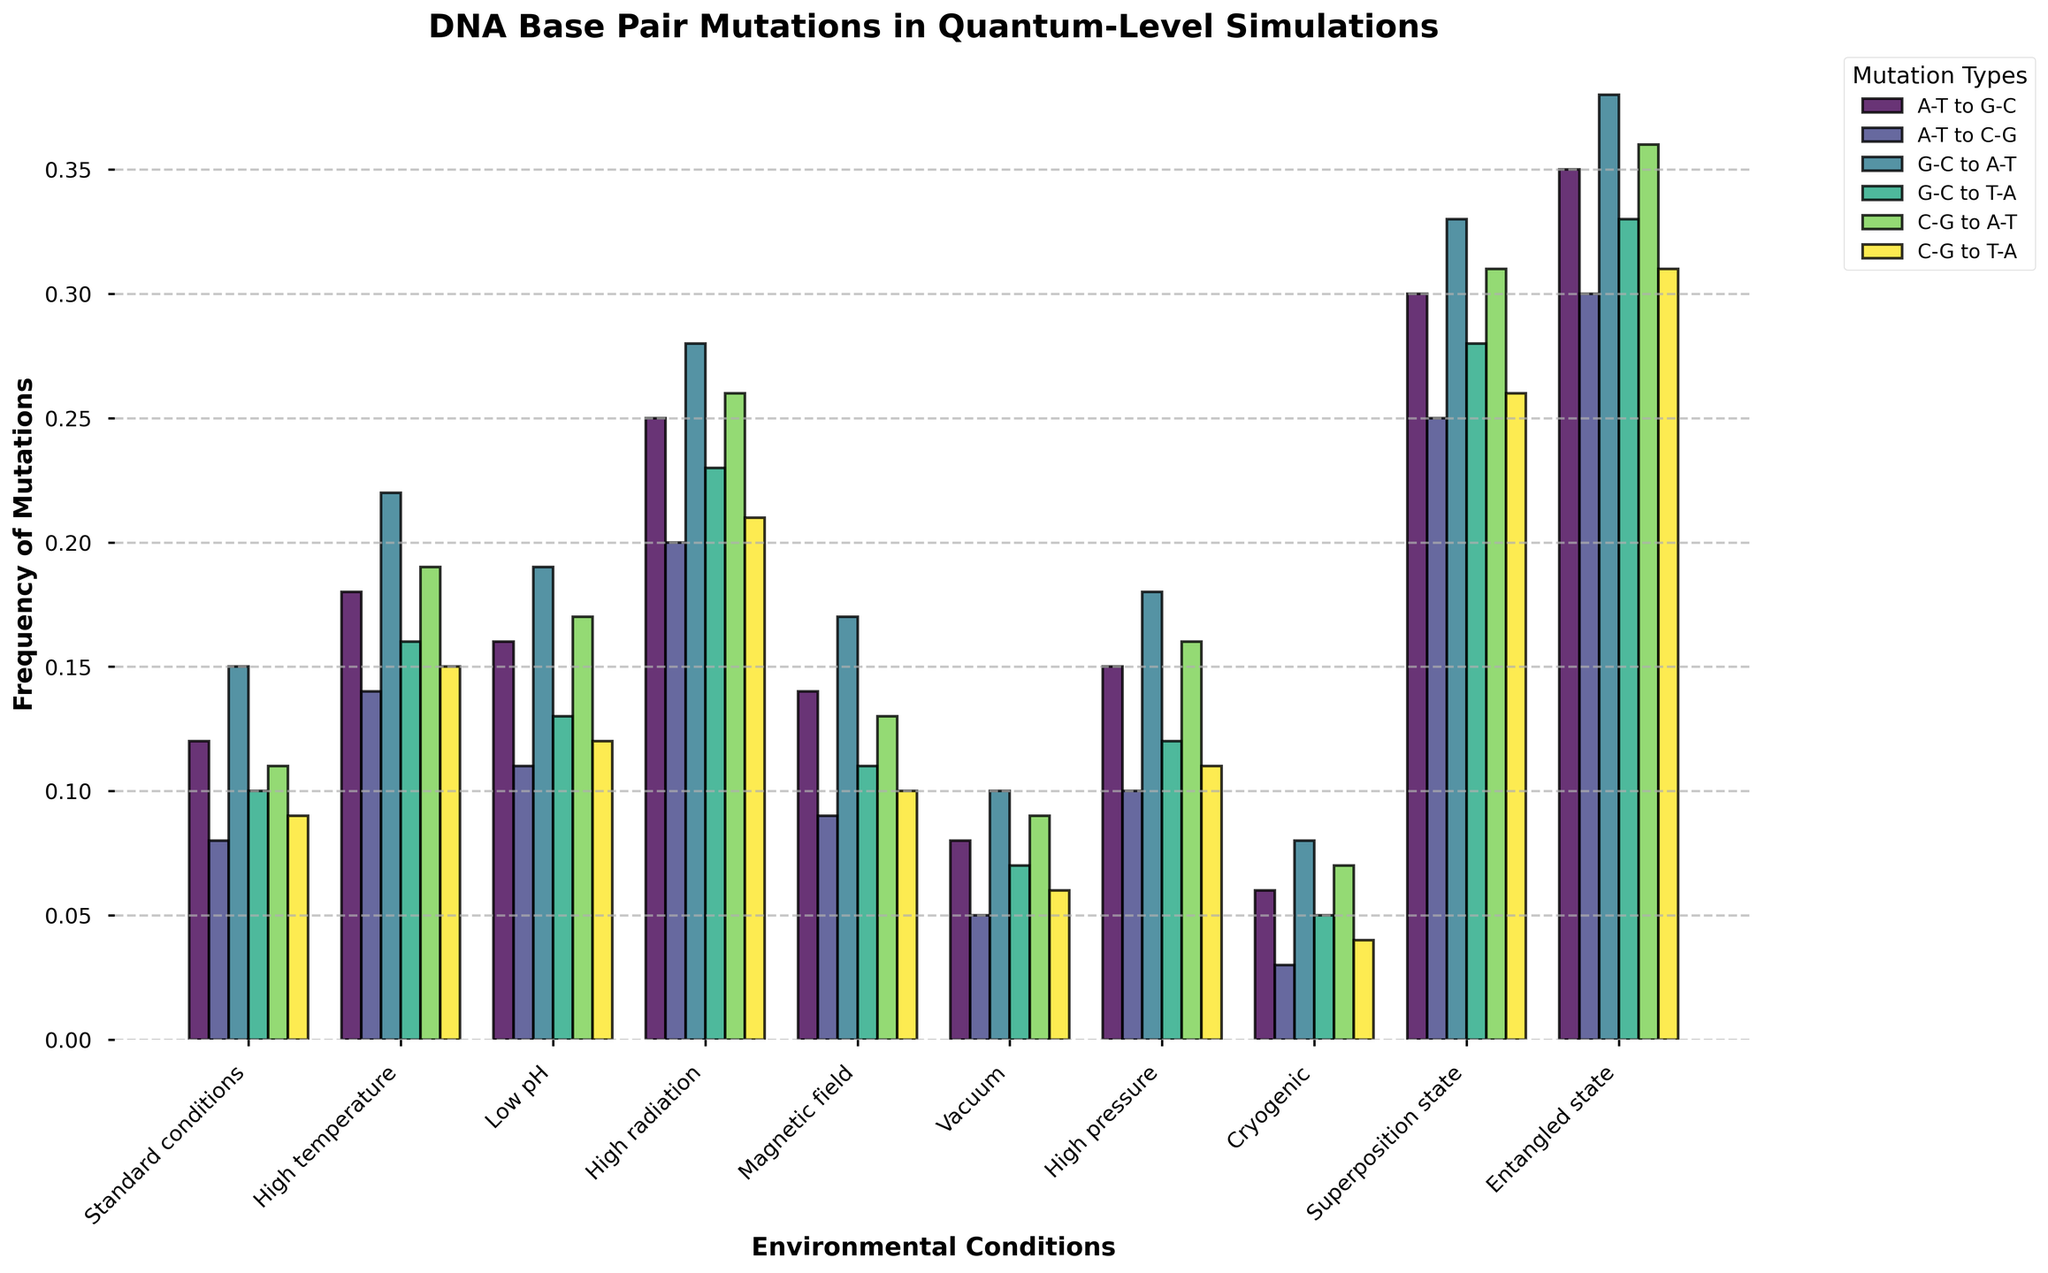Which environmental condition shows the highest frequency for the "G-C to T-A" mutation? The highest frequency for the "G-C to T-A" mutation is seen in the "Entangled state". The bar representing "G-C to T-A" in the "Entangled state" is the tallest among all environmental conditions.
Answer: Entangled state Comparing "Standard conditions" and "High temperature", which mutation type has the largest difference in frequency? For each mutation type, subtract the frequency in "Standard conditions" from the frequency in "High temperature". The largest difference is for the "G-C to A-T" mutation (0.22 - 0.15 = 0.07).
Answer: G-C to A-T What is the average frequency of the "A-T to G-C" mutation across all environmental conditions? Sum the frequencies of the "A-T to G-C" mutation across all conditions and divide by the number of conditions. (0.12 + 0.18 + 0.16 + 0.25 + 0.14 + 0.08 + 0.15 + 0.06 + 0.30 + 0.35) / 10 = 1.79 / 10 = 0.179
Answer: 0.179 Which environmental condition has the lowest combined frequency of "C-G to A-T" and "C-G to T-A" mutations? Add the frequencies of "C-G to A-T" and "C-G to T-A" for each condition. The "Cryogenic" condition has the lowest combined frequency (0.07 + 0.04 = 0.11).
Answer: Cryogenic How does the frequency of the "A-T to C-G" mutation change from "Standard conditions" to "High pressure"? The frequency of the "A-T to C-G" mutation increases from 0.08 in "Standard conditions" to 0.10 in "High pressure". The difference is 0.10 - 0.08 = 0.02.
Answer: Increases by 0.02 Under which environmental condition is the "G-C to A-T" mutation seen more frequently, "Low pH" or "Vacuum"? Compare the heights of the bars for "G-C to A-T" under "Low pH" (0.19) and "Vacuum" (0.10). The "G-C to A-T" mutation is more frequent under "Low pH".
Answer: Low pH What is the total frequency of all mutations in the "Entangled state"? Add the frequencies of all mutations in the "Entangled state": 0.35 + 0.30 + 0.38 + 0.33 + 0.36 + 0.31 = 2.03.
Answer: 2.03 Which mutation type shows the highest frequency across all environmental conditions? The mutation type "G-C to A-T" in the "Entangled state" has the highest frequency (0.38), as it is the tallest bar among all mutation types and conditions.
Answer: G-C to A-T 